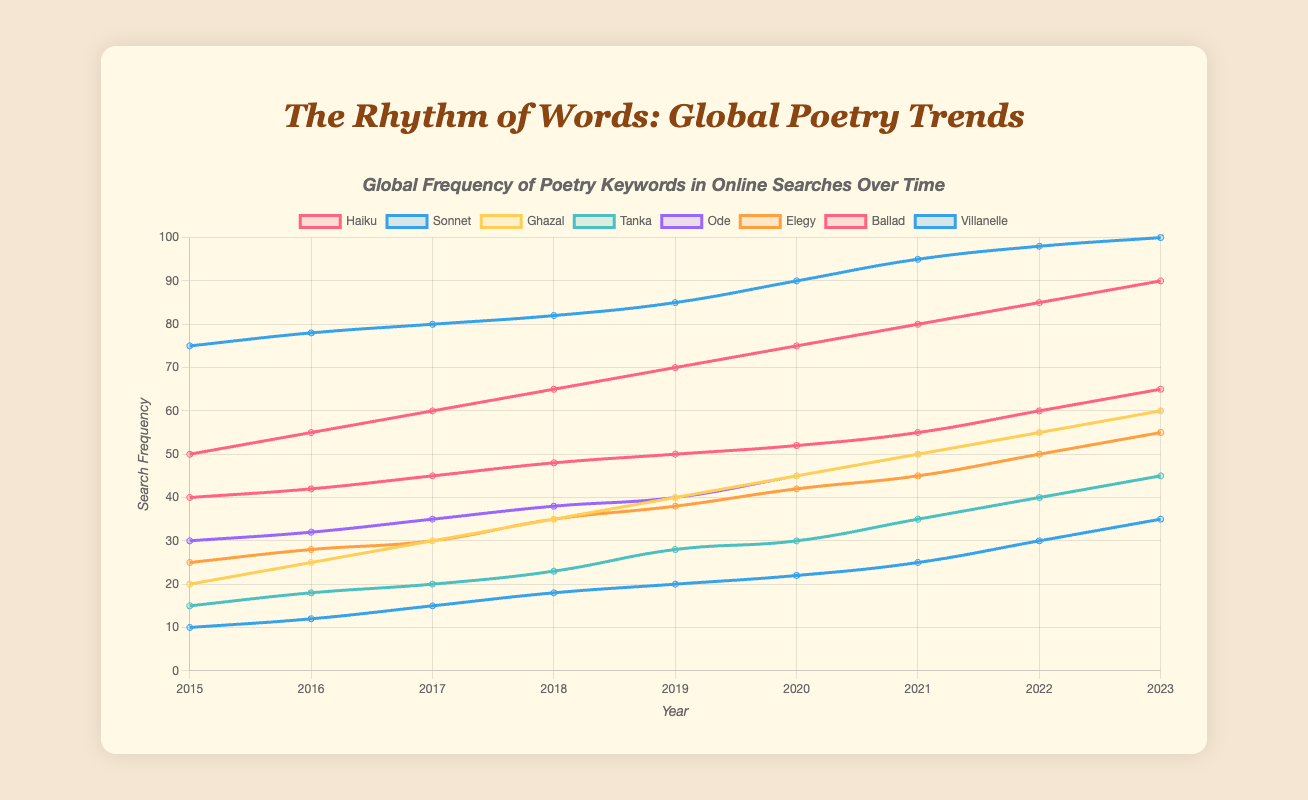What poetry keyword experienced the most significant increase in search frequency from 2015 to 2023? To answer this, look at the starting and ending values for each keyword in 2015 and 2023. Calculate the increase for each:
- Haiku: 90 - 50 = 40
- Sonnet: 100 - 75 = 25
- Ghazal: 60 - 20 = 40
- Tanka: 45 - 15 = 30
- Ode: 60 - 30 = 30
- Elegy: 55 - 25 = 30
- Ballad: 65 - 40 = 25
- Villanelle: 35 - 10 = 25
Haiku and Ghazal both experienced the largest increase of 40.
Answer: Haiku and Ghazal Which poetry keyword had the highest search frequency in 2020? To find this, look at the highest value among the poetry keywords for the year 2020:
- Haiku: 75
- Sonnet: 90
- Ghazal: 45
- Tanka: 30
- Ode: 45
- Elegy: 42
- Ballad: 52
- Villanelle: 22
Sonnet has the highest value of 90.
Answer: Sonnet Compare the search frequency of Ballad and Villanelle in 2023. Which one is higher and by how much? Look at the values for Ballad and Villanelle in 2023:
- Ballad: 65
- Villanelle: 35
Subtract Villanelle's value from Ballad's value: 65 - 35 = 30.
Ballad's search frequency is 30 higher.
Answer: Ballad by 30 What is the average search frequency for the keyword 'Ode' over the years presented? Add the search frequencies of 'Ode' for each year and divide by the number of years (9):
(30 + 32 + 35 + 38 + 40 + 45 + 50 + 55 + 60) / 9 = 385 / 9 ≈ 42.78
Answer: 42.78 Which keywords show a consistent increase in search frequency every year from 2015 to 2023? Check each keyword for consistent year-to-year increases:
- Haiku: Consistent increase
- Sonnet: Consistent increase
- Ghazal: Consistent increase
- Tanka: Consistent increase
- Ode: Consistent increase
- Elegy: Consistent increase
- Ballad: Consistent increase
- Villanelle: Consistent increase
All keywords show a consistent increase.
Answer: All In which year did Tanka surpass 20 in search frequency, and what was its value that year? Look for the first year where Tanka's value is greater than 20:
- 2015: 15
- 2016: 18
- 2017: 20
- 2018: 23 (first year > 20)
Answer: 2018, 23 Compare the search frequencies of Haiku and Ghazal from 2015 to 2017. Which keyword had a higher search frequency overall during this period? Add the search frequencies from 2015 to 2017 for each keyword and compare:
- Haiku: 50 + 55 + 60 = 165
- Ghazal: 20 + 25 + 30 = 75
Haiku had a higher overall search frequency.
Answer: Haiku Between 2015 and 2018, which year had the highest combined search frequency for all keywords? Calculate the combined search frequency for each year from 2015 to 2018:
- 2015: 50 + 75 + 20 + 15 + 30 + 25 + 40 + 10 = 265
- 2016: 55 + 78 + 25 + 18 + 32 + 28 + 42 + 12 = 290
- 2017: 60 + 80 + 30 + 20 + 35 + 30 + 45 + 15 = 315
- 2018: 65 + 82 + 35 + 23 + 38 + 35 + 48 + 18 = 344
2018 had the highest combined search frequency of 344.
Answer: 2018 What is the total number of unique keywords tracked in this dataset? Count the number of unique keywords mentioned:
- haiku, sonnet, ghazal, tanka, ode, elegy, ballad, villanelle
There are 8 unique keywords.
Answer: 8 